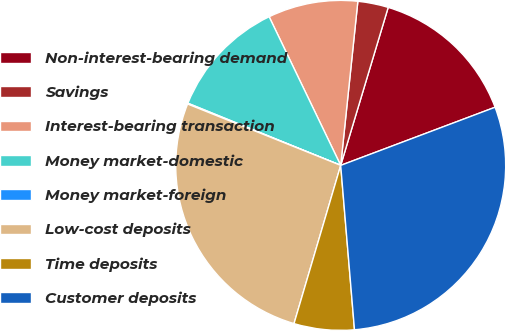<chart> <loc_0><loc_0><loc_500><loc_500><pie_chart><fcel>Non-interest-bearing demand<fcel>Savings<fcel>Interest-bearing transaction<fcel>Money market-domestic<fcel>Money market-foreign<fcel>Low-cost deposits<fcel>Time deposits<fcel>Customer deposits<nl><fcel>14.62%<fcel>2.99%<fcel>8.8%<fcel>11.71%<fcel>0.08%<fcel>26.5%<fcel>5.9%<fcel>29.4%<nl></chart> 